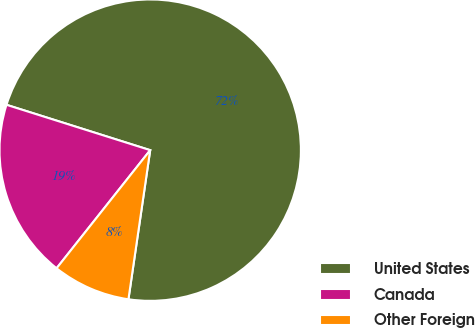<chart> <loc_0><loc_0><loc_500><loc_500><pie_chart><fcel>United States<fcel>Canada<fcel>Other Foreign<nl><fcel>72.44%<fcel>19.2%<fcel>8.36%<nl></chart> 